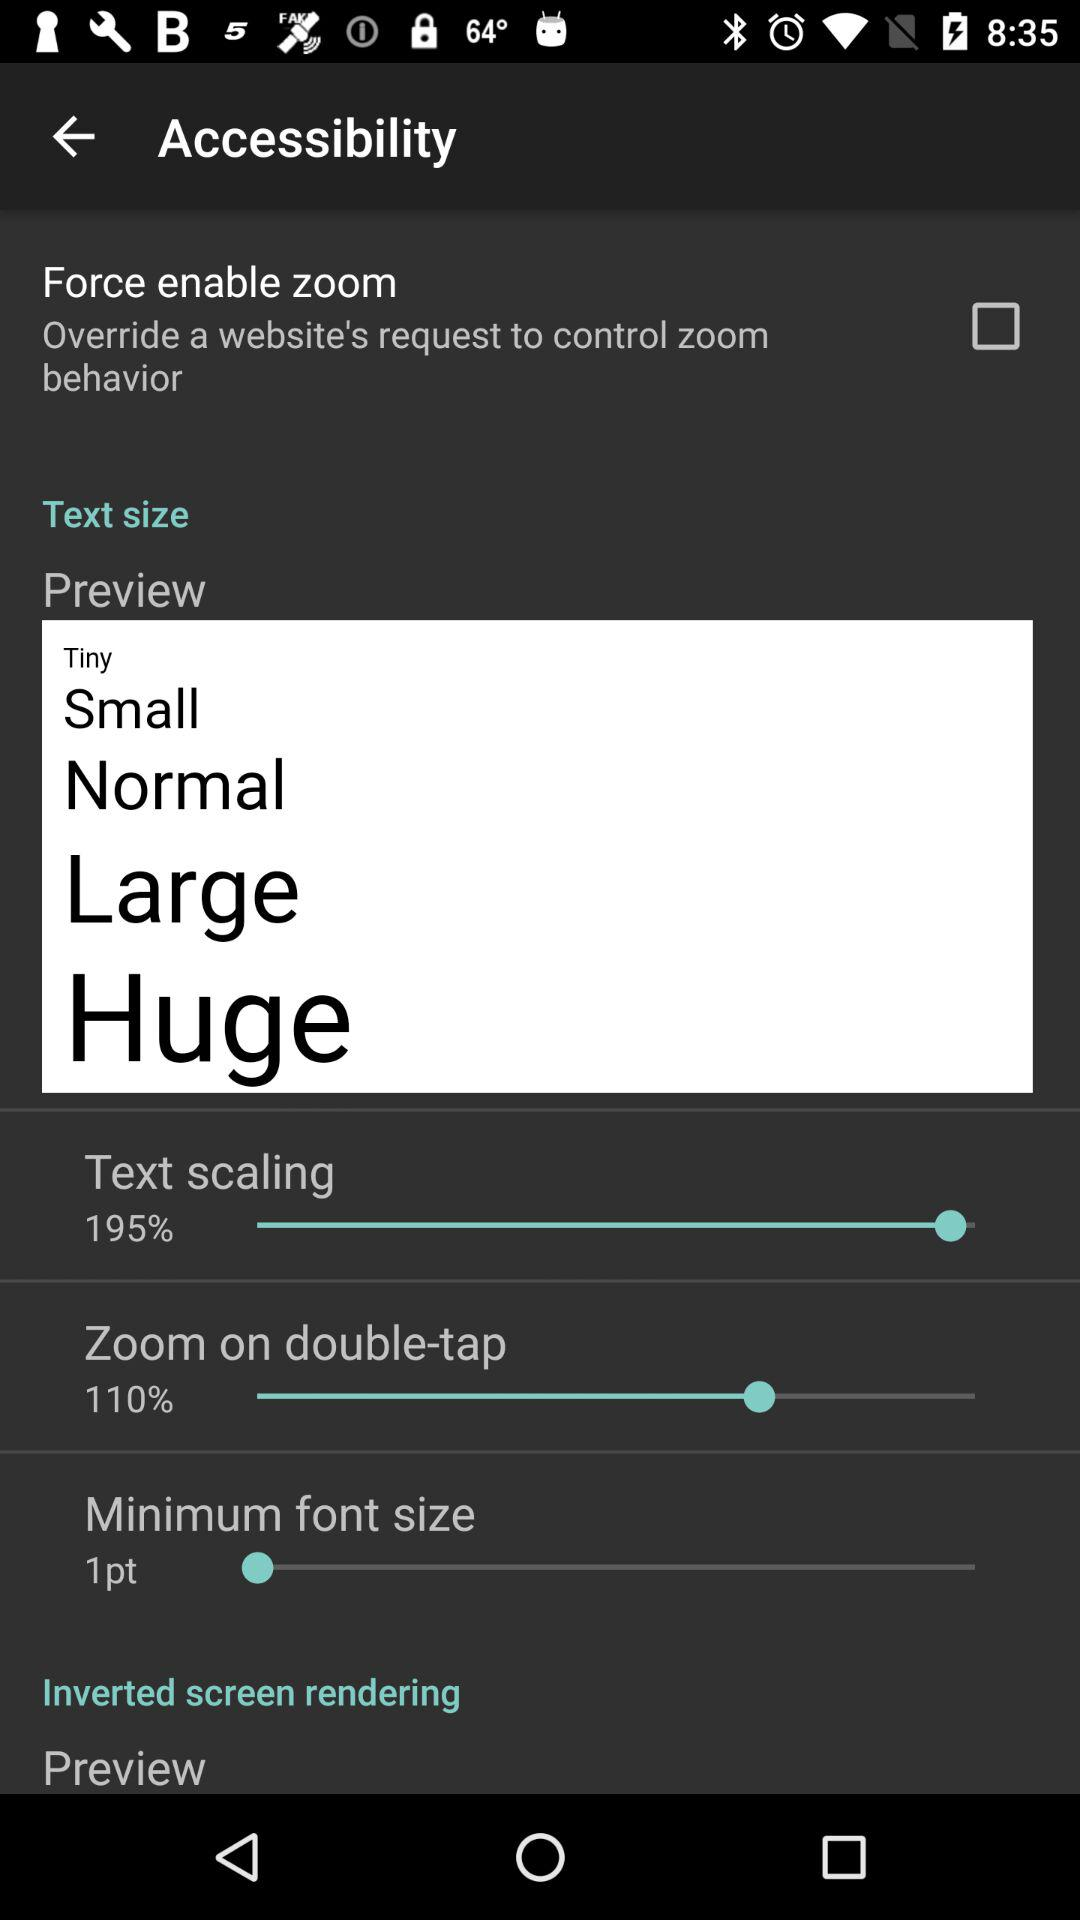What is the status of "Force enable zoom"? The status is "off". 